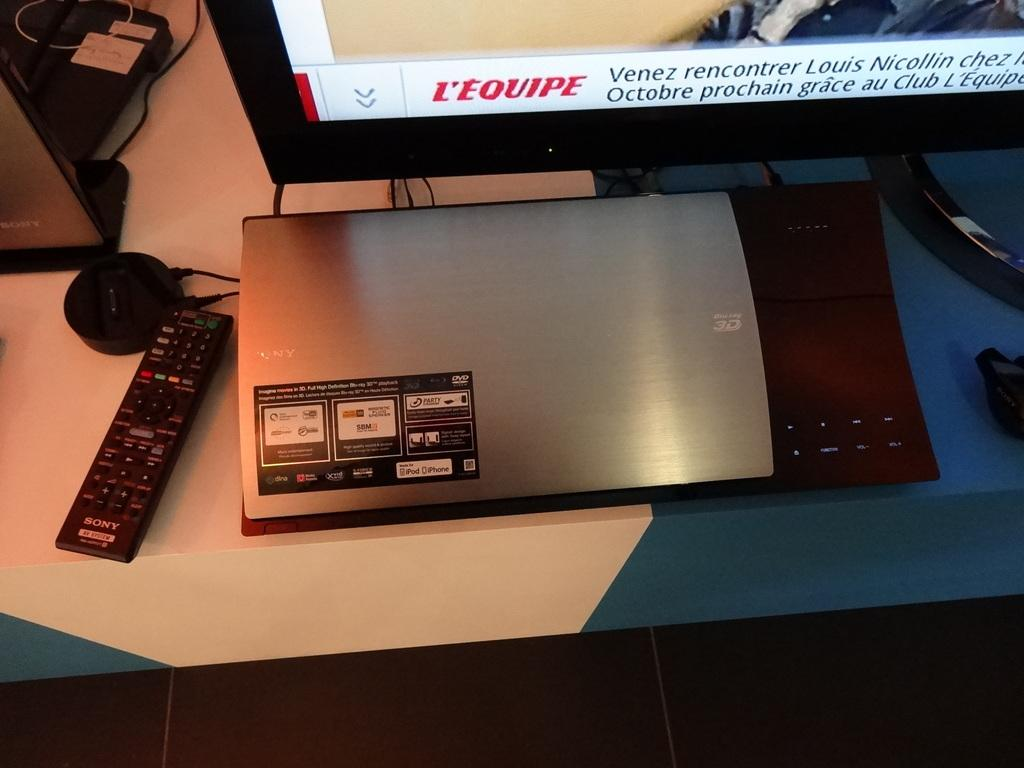<image>
Write a terse but informative summary of the picture. A computer with an illuminated screen that reads L'Equipe. 